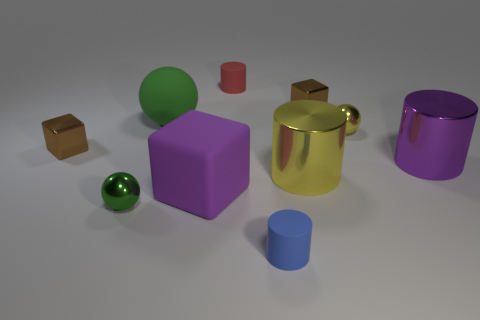The small object that is the same color as the rubber sphere is what shape?
Provide a succinct answer. Sphere. There is a big green ball that is on the right side of the tiny green metallic ball; what material is it?
Offer a very short reply. Rubber. Does the purple shiny object have the same size as the yellow sphere?
Give a very brief answer. No. Are there more metal cubes that are on the right side of the large purple rubber thing than small spheres?
Ensure brevity in your answer.  No. What is the size of the purple object that is the same material as the tiny red cylinder?
Provide a short and direct response. Large. There is a tiny blue rubber cylinder; are there any purple cylinders in front of it?
Keep it short and to the point. No. Does the tiny red thing have the same shape as the tiny yellow thing?
Offer a terse response. No. There is a brown shiny cube to the left of the ball that is in front of the big cylinder that is to the right of the small yellow ball; what size is it?
Your answer should be compact. Small. What material is the tiny yellow ball?
Offer a terse response. Metal. There is a shiny object that is the same color as the large matte block; what size is it?
Make the answer very short. Large. 